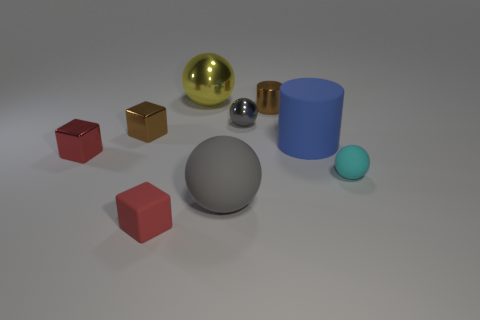What color is the small matte thing that is behind the small red rubber object?
Provide a succinct answer. Cyan. How many things are either cubes behind the cyan thing or shiny objects that are to the left of the gray rubber ball?
Your response must be concise. 3. How many other gray objects have the same shape as the small gray metallic object?
Provide a short and direct response. 1. The cylinder that is the same size as the gray matte ball is what color?
Keep it short and to the point. Blue. There is a cylinder that is in front of the brown metallic thing that is on the right side of the small matte object that is to the left of the big matte sphere; what color is it?
Offer a terse response. Blue. Do the blue matte thing and the red block on the right side of the tiny brown cube have the same size?
Make the answer very short. No. How many things are small gray metal blocks or gray balls?
Offer a very short reply. 2. Is there another thing made of the same material as the big blue object?
Your answer should be very brief. Yes. There is a shiny thing that is the same color as the tiny cylinder; what is its size?
Give a very brief answer. Small. What is the color of the small shiny cube that is on the right side of the tiny shiny object that is in front of the tiny brown shiny block?
Keep it short and to the point. Brown. 